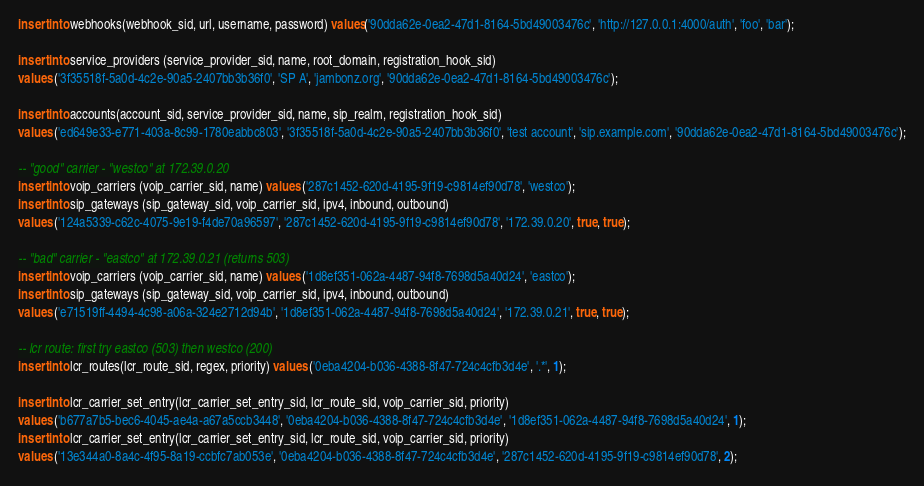<code> <loc_0><loc_0><loc_500><loc_500><_SQL_>insert into webhooks(webhook_sid, url, username, password) values('90dda62e-0ea2-47d1-8164-5bd49003476c', 'http://127.0.0.1:4000/auth', 'foo', 'bar');

insert into service_providers (service_provider_sid, name, root_domain, registration_hook_sid) 
values ('3f35518f-5a0d-4c2e-90a5-2407bb3b36f0', 'SP A', 'jambonz.org', '90dda62e-0ea2-47d1-8164-5bd49003476c');

insert into accounts(account_sid, service_provider_sid, name, sip_realm, registration_hook_sid)
values ('ed649e33-e771-403a-8c99-1780eabbc803', '3f35518f-5a0d-4c2e-90a5-2407bb3b36f0', 'test account', 'sip.example.com', '90dda62e-0ea2-47d1-8164-5bd49003476c');

-- "good" carrier - "westco" at 172.39.0.20
insert into voip_carriers (voip_carrier_sid, name) values ('287c1452-620d-4195-9f19-c9814ef90d78', 'westco');
insert into sip_gateways (sip_gateway_sid, voip_carrier_sid, ipv4, inbound, outbound) 
values ('124a5339-c62c-4075-9e19-f4de70a96597', '287c1452-620d-4195-9f19-c9814ef90d78', '172.39.0.20', true, true);

-- "bad" carrier - "eastco" at 172.39.0.21 (returns 503)
insert into voip_carriers (voip_carrier_sid, name) values ('1d8ef351-062a-4487-94f8-7698d5a40d24', 'eastco');
insert into sip_gateways (sip_gateway_sid, voip_carrier_sid, ipv4, inbound, outbound) 
values ('e71519ff-4494-4c98-a06a-324e2712d94b', '1d8ef351-062a-4487-94f8-7698d5a40d24', '172.39.0.21', true, true);

-- lcr route: first try eastco (503) then westco (200)
insert into lcr_routes(lcr_route_sid, regex, priority) values ('0eba4204-b036-4388-8f47-724c4cfb3d4e', '.*', 1);

insert into lcr_carrier_set_entry(lcr_carrier_set_entry_sid, lcr_route_sid, voip_carrier_sid, priority)
values ('b677a7b5-bec6-4045-ae4a-a67a5ccb3448', '0eba4204-b036-4388-8f47-724c4cfb3d4e', '1d8ef351-062a-4487-94f8-7698d5a40d24', 1);
insert into lcr_carrier_set_entry(lcr_carrier_set_entry_sid, lcr_route_sid, voip_carrier_sid, priority)
values ('13e344a0-8a4c-4f95-8a19-ccbfc7ab053e', '0eba4204-b036-4388-8f47-724c4cfb3d4e', '287c1452-620d-4195-9f19-c9814ef90d78', 2);

</code> 